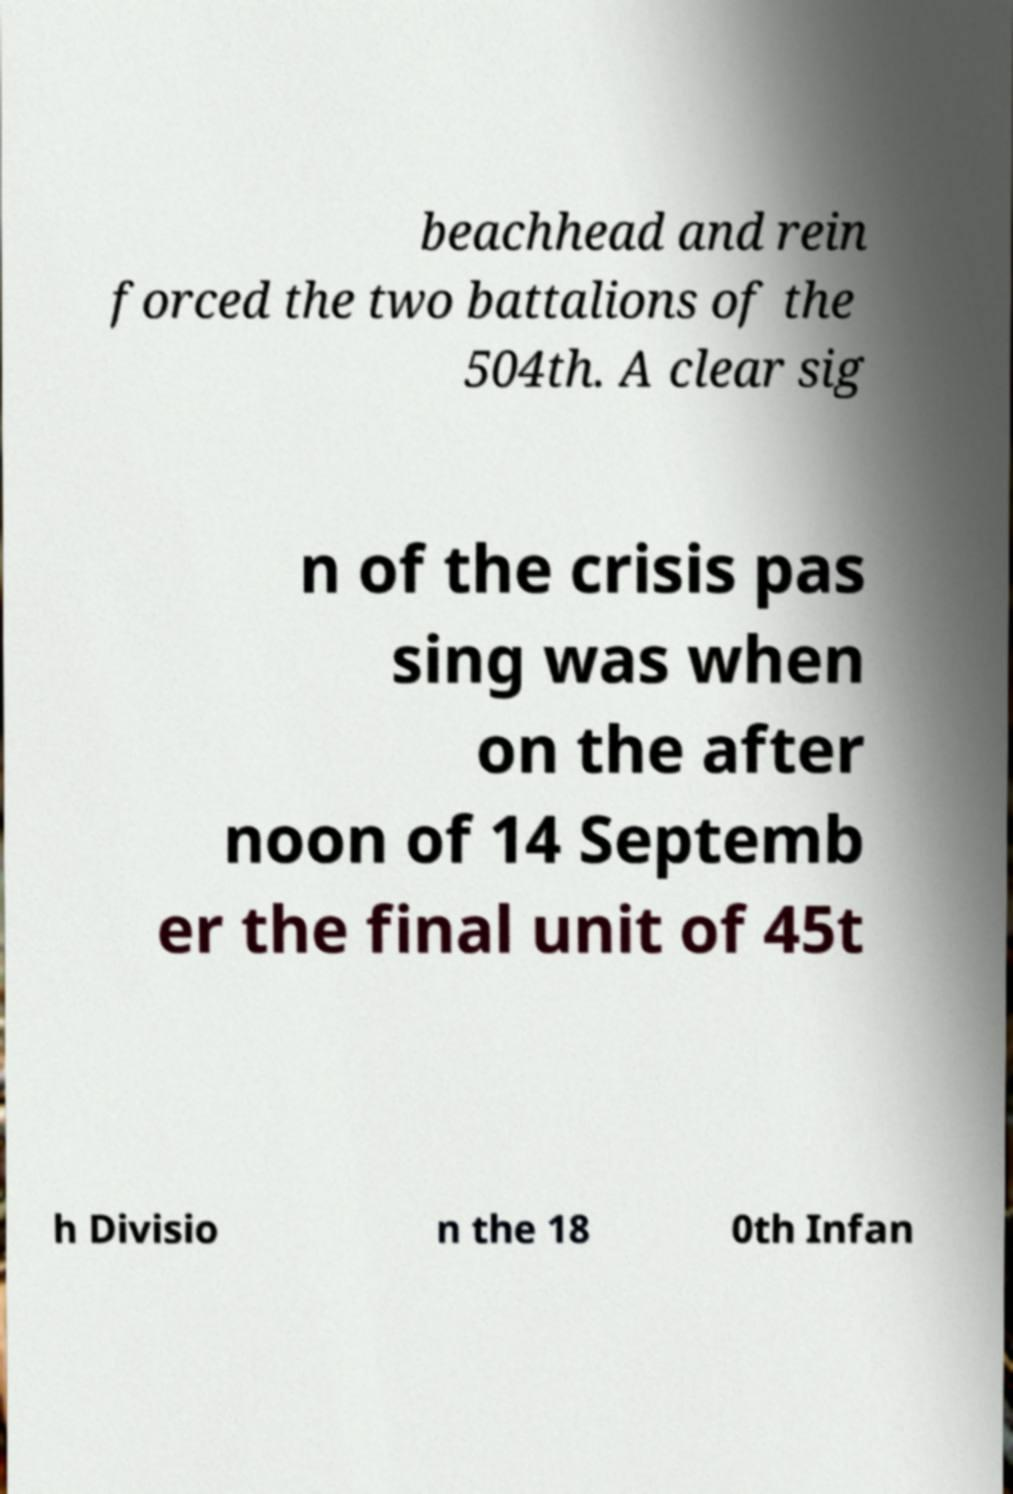There's text embedded in this image that I need extracted. Can you transcribe it verbatim? beachhead and rein forced the two battalions of the 504th. A clear sig n of the crisis pas sing was when on the after noon of 14 Septemb er the final unit of 45t h Divisio n the 18 0th Infan 